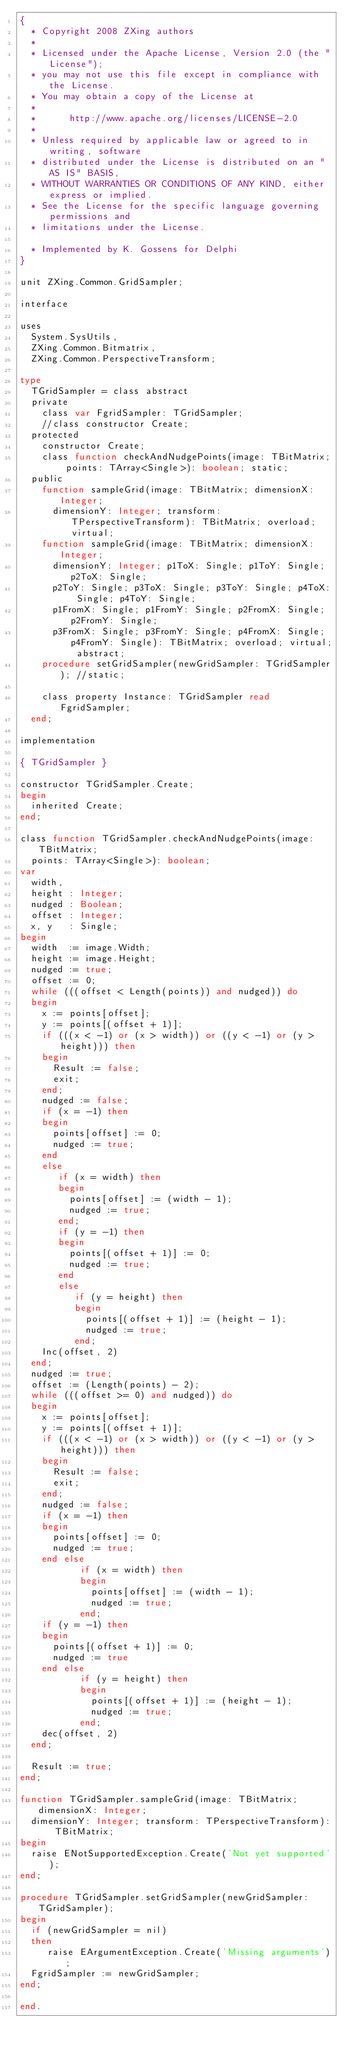Convert code to text. <code><loc_0><loc_0><loc_500><loc_500><_Pascal_>{
  * Copyright 2008 ZXing authors
  *
  * Licensed under the Apache License, Version 2.0 (the "License");
  * you may not use this file except in compliance with the License.
  * You may obtain a copy of the License at
  *
  *      http://www.apache.org/licenses/LICENSE-2.0
  *
  * Unless required by applicable law or agreed to in writing, software
  * distributed under the License is distributed on an "AS IS" BASIS,
  * WITHOUT WARRANTIES OR CONDITIONS OF ANY KIND, either express or implied.
  * See the License for the specific language governing permissions and
  * limitations under the License.

  * Implemented by K. Gossens for Delphi
}

unit ZXing.Common.GridSampler;

interface

uses
  System.SysUtils,
  ZXing.Common.Bitmatrix,
  ZXing.Common.PerspectiveTransform;

type
  TGridSampler = class abstract
  private
    class var FgridSampler: TGridSampler;
    //class constructor Create;
  protected
    constructor Create;
    class function checkAndNudgePoints(image: TBitMatrix; points: TArray<Single>): boolean; static;
  public
    function sampleGrid(image: TBitMatrix; dimensionX: Integer;
      dimensionY: Integer; transform: TPerspectiveTransform): TBitMatrix; overload; virtual;
    function sampleGrid(image: TBitMatrix; dimensionX: Integer;
      dimensionY: Integer; p1ToX: Single; p1ToY: Single; p2ToX: Single;
      p2ToY: Single; p3ToX: Single; p3ToY: Single; p4ToX: Single; p4ToY: Single;
      p1FromX: Single; p1FromY: Single; p2FromX: Single; p2FromY: Single;
      p3FromX: Single; p3FromY: Single; p4FromX: Single; p4FromY: Single): TBitMatrix; overload; virtual; abstract;
    procedure setGridSampler(newGridSampler: TGridSampler); //static;

    class property Instance: TGridSampler read FgridSampler;
  end;

implementation

{ TGridSampler }

constructor TGridSampler.Create;
begin
  inherited Create;
end;

class function TGridSampler.checkAndNudgePoints(image: TBitMatrix;
  points: TArray<Single>): boolean;
var
  width,
  height : Integer;
  nudged : Boolean;
  offset : Integer;
  x, y   : Single;
begin
  width  := image.Width;
  height := image.Height;
  nudged := true;
  offset := 0;
  while (((offset < Length(points)) and nudged)) do
  begin
    x := points[offset];
    y := points[(offset + 1)];
    if (((x < -1) or (x > width)) or ((y < -1) or (y > height))) then
    begin
      Result := false;
      exit;
    end;
    nudged := false;
    if (x = -1) then
    begin
      points[offset] := 0;
      nudged := true;
    end
    else
       if (x = width) then
       begin
         points[offset] := (width - 1);
         nudged := true;
       end;
       if (y = -1) then
       begin
         points[(offset + 1)] := 0;
         nudged := true;
       end
       else
          if (y = height) then
          begin
            points[(offset + 1)] := (height - 1);
            nudged := true;
          end;
    Inc(offset, 2)
  end;
  nudged := true;
  offset := (Length(points) - 2);
  while (((offset >= 0) and nudged)) do
  begin
    x := points[offset];
    y := points[(offset + 1)];
    if (((x < -1) or (x > width)) or ((y < -1) or (y > height))) then
    begin
      Result := false;
      exit;
    end;
    nudged := false;
    if (x = -1) then
    begin
      points[offset] := 0;
      nudged := true;
    end else
           if (x = width) then
           begin
             points[offset] := (width - 1);
             nudged := true;
           end;
    if (y = -1) then
    begin
      points[(offset + 1)] := 0;
      nudged := true
    end else
           if (y = height) then
           begin
             points[(offset + 1)] := (height - 1);
             nudged := true;
           end;
    dec(offset, 2)
  end;

  Result := true;
end;

function TGridSampler.sampleGrid(image: TBitMatrix; dimensionX: Integer;
  dimensionY: Integer; transform: TPerspectiveTransform): TBitMatrix;
begin
  raise ENotSupportedException.Create('Not yet supported');
end;

procedure TGridSampler.setGridSampler(newGridSampler: TGridSampler);
begin
  if (newGridSampler = nil)
  then
     raise EArgumentException.Create('Missing arguments');
  FgridSampler := newGridSampler;
end;

end.</code> 